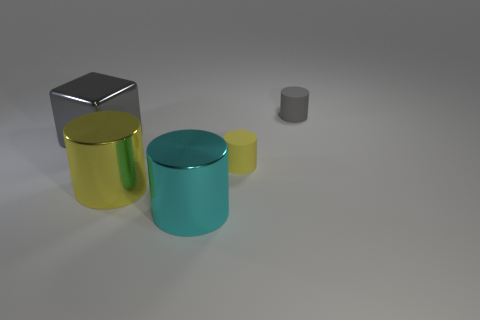There is a gray thing in front of the small object to the right of the tiny yellow cylinder; what is its shape? The gray object you're referring to is indeed shaped like a cube. It has a distinctly geometric form with six equal square faces and represents a perfect example of a three-dimensional cube in the image. 